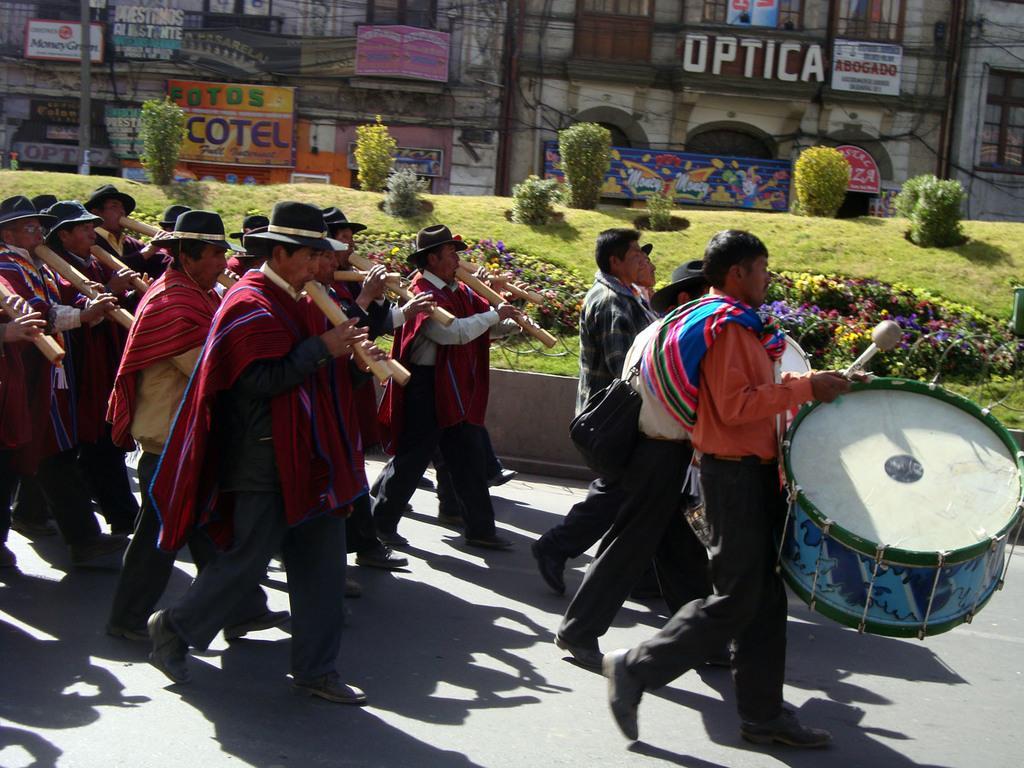Can you describe this image briefly? There are group of persons playing music and there are trees,grass and buildings beside them. 